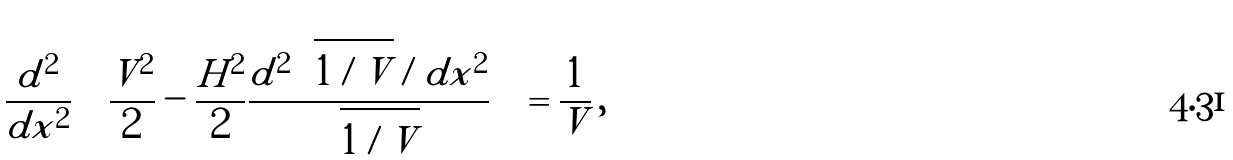Convert formula to latex. <formula><loc_0><loc_0><loc_500><loc_500>\frac { d ^ { 2 } } { d x ^ { 2 } } \left ( \frac { V ^ { 2 } } { 2 } - \frac { H ^ { 2 } } { 2 } \frac { d ^ { 2 } \sqrt { 1 / V } / d x ^ { 2 } } { \sqrt { 1 / V } } \right ) = \frac { 1 } { V } \, ,</formula> 